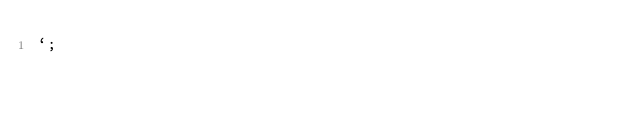<code> <loc_0><loc_0><loc_500><loc_500><_JavaScript_>`;
</code> 